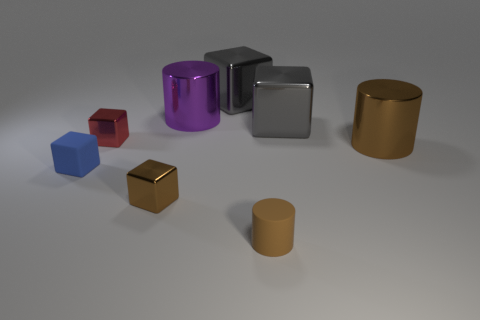Is the number of large yellow metal objects less than the number of cylinders? Indeed, the number of large yellow metal objects, which appears to be one, is less than the number of cylinders present, totaling three — two metallic cylinders and one purple. 